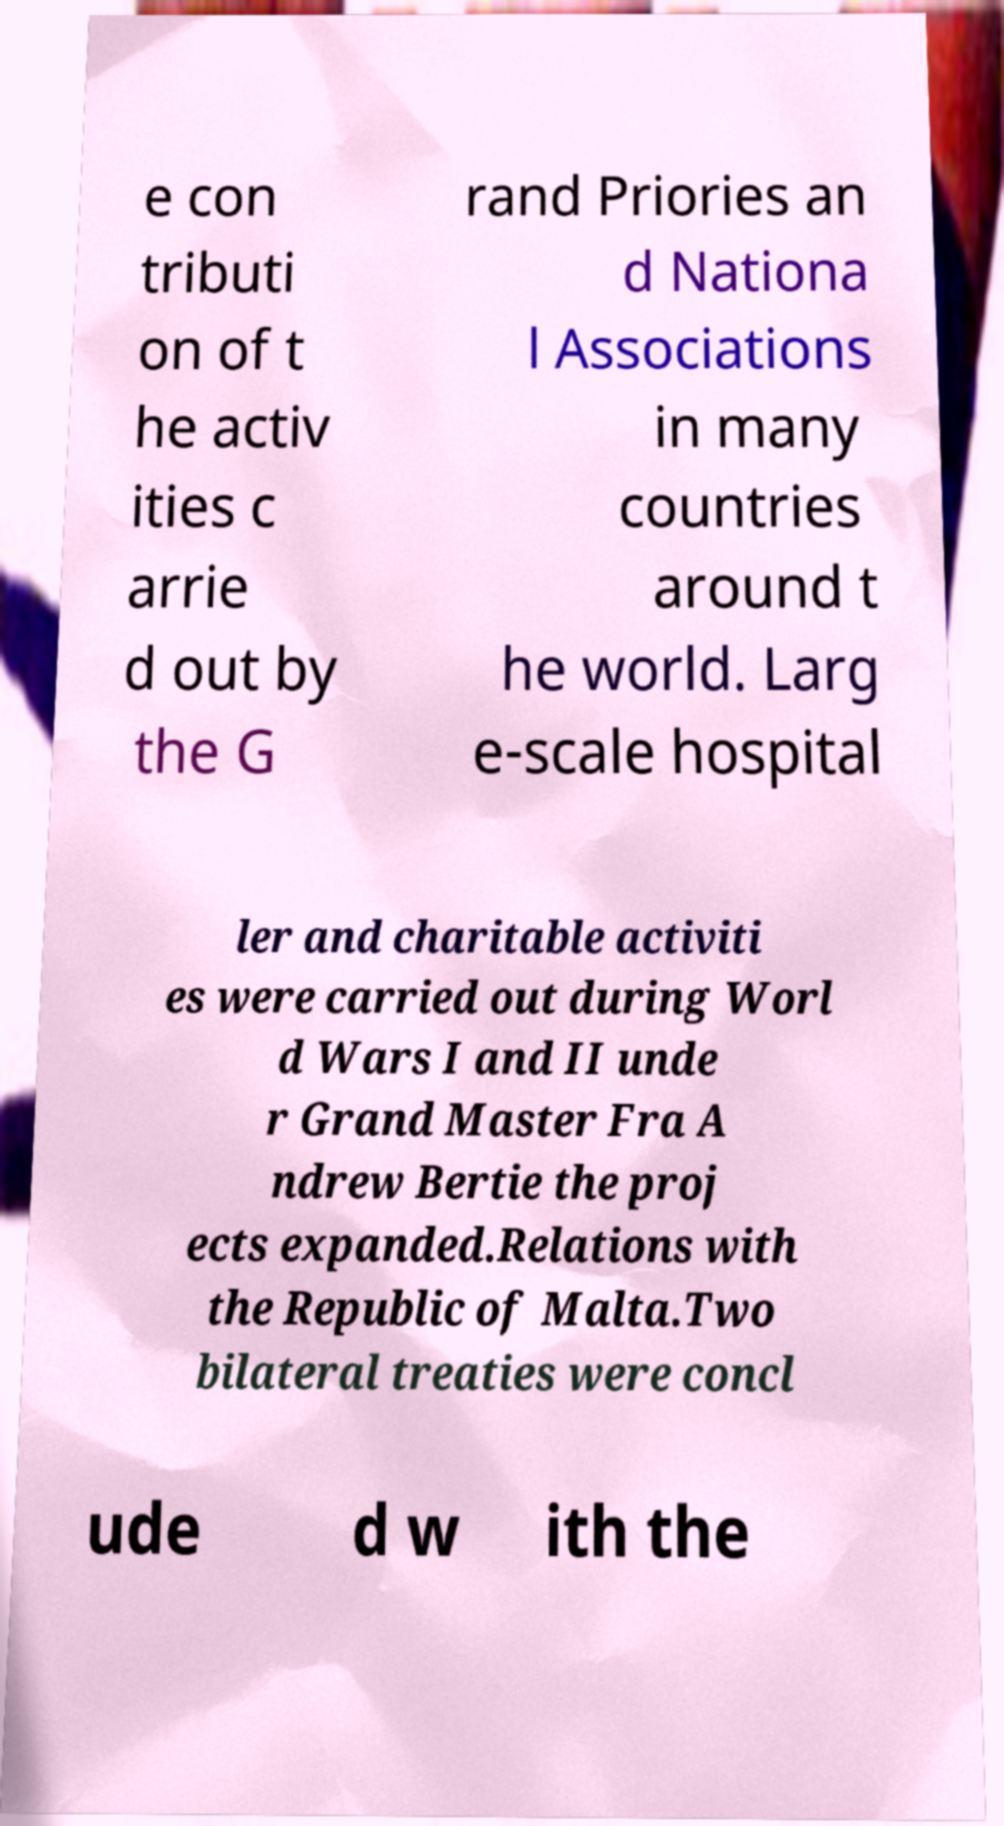Could you extract and type out the text from this image? e con tributi on of t he activ ities c arrie d out by the G rand Priories an d Nationa l Associations in many countries around t he world. Larg e-scale hospital ler and charitable activiti es were carried out during Worl d Wars I and II unde r Grand Master Fra A ndrew Bertie the proj ects expanded.Relations with the Republic of Malta.Two bilateral treaties were concl ude d w ith the 